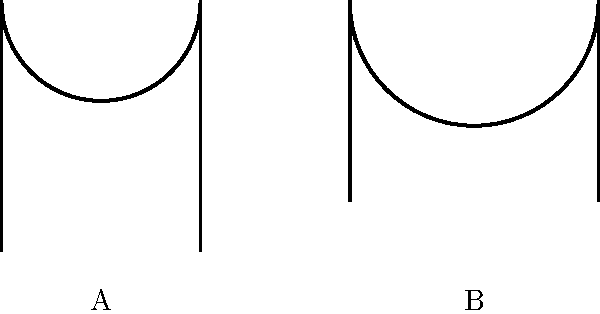As a novelist drawing inspiration from museums for your historical romance, you come across these sketches of two different arch styles. Which architectural period is represented by arch A, and how does it differ from arch B? To answer this question, let's analyze the characteristics of both arches:

1. Arch A:
   - It has a pointed top, forming a sharp angle at the apex.
   - The sides of the arch rise steeply and meet at a point.
   - This pointed shape is characteristic of Gothic architecture.

2. Arch B:
   - It has a rounded top, forming a semicircle.
   - The curve is uniform from one side to the other.
   - This rounded shape is typical of Romanesque architecture.

The key differences between the two arches are:

1. Shape: Gothic (A) is pointed, while Romanesque (B) is rounded.
2. Height-to-width ratio: Gothic arches tend to be taller and narrower, while Romanesque arches are typically wider in proportion to their height.
3. Structural implications: Gothic arches distribute weight more efficiently, allowing for taller, more open structures, while Romanesque arches require thicker walls for support.

In historical context:
- Gothic architecture emerged in the 12th century and was prevalent until the 16th century.
- Romanesque architecture preceded Gothic, flourishing from the 6th to the 11th centuries.

For a historical romance novelist, understanding these architectural styles can help in accurately describing buildings and settings from different periods, adding authenticity to the narrative and enhancing the reader's immersion in the historical setting.
Answer: Gothic; pointed vs. rounded 